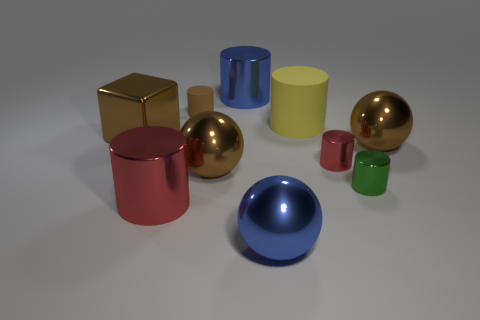Do the blue object to the right of the blue metallic cylinder and the green cylinder have the same material?
Your response must be concise. Yes. Is the number of tiny metal cylinders that are to the left of the big red cylinder the same as the number of red cylinders on the right side of the large blue cylinder?
Offer a terse response. No. There is a tiny thing that is the same color as the big cube; what is it made of?
Keep it short and to the point. Rubber. There is a red thing that is behind the green metal thing; how many blue balls are behind it?
Make the answer very short. 0. There is a large metallic thing that is behind the brown shiny cube; is it the same color as the ball in front of the big red metal cylinder?
Offer a very short reply. Yes. What material is the brown cylinder that is the same size as the green thing?
Ensure brevity in your answer.  Rubber. The small object on the left side of the big sphere that is to the left of the metal object behind the small rubber cylinder is what shape?
Make the answer very short. Cylinder. What shape is the matte object that is the same size as the blue sphere?
Offer a terse response. Cylinder. There is a red metal cylinder right of the tiny object behind the brown metallic block; how many big metal balls are on the left side of it?
Keep it short and to the point. 2. Are there more large blue metal spheres right of the blue ball than blue metal cylinders left of the big metallic block?
Ensure brevity in your answer.  No. 